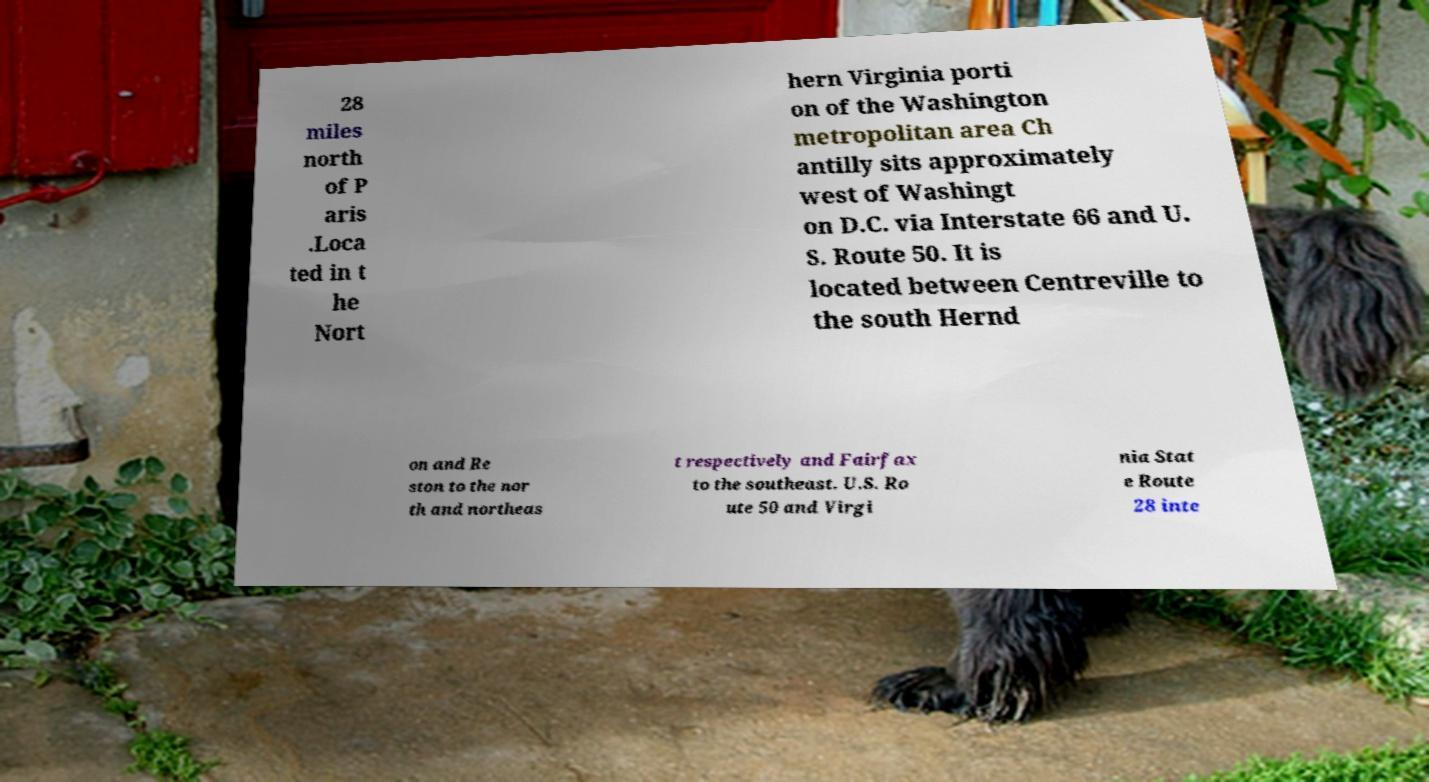Please identify and transcribe the text found in this image. 28 miles north of P aris .Loca ted in t he Nort hern Virginia porti on of the Washington metropolitan area Ch antilly sits approximately west of Washingt on D.C. via Interstate 66 and U. S. Route 50. It is located between Centreville to the south Hernd on and Re ston to the nor th and northeas t respectively and Fairfax to the southeast. U.S. Ro ute 50 and Virgi nia Stat e Route 28 inte 